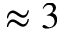<formula> <loc_0><loc_0><loc_500><loc_500>\approx 3</formula> 